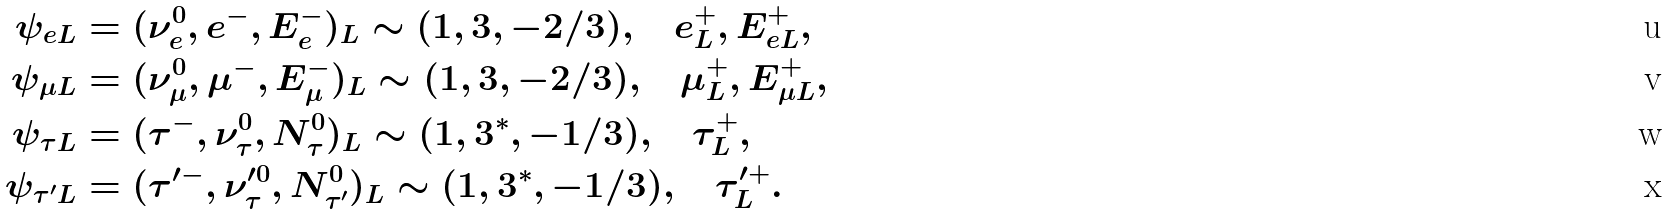<formula> <loc_0><loc_0><loc_500><loc_500>\psi _ { e L } & = ( \nu _ { e } ^ { 0 } , e ^ { - } , E ^ { - } _ { e } ) _ { L } \sim ( 1 , 3 , - 2 / 3 ) , \quad e ^ { + } _ { L } , E _ { e L } ^ { + } , \\ \psi _ { \mu L } & = ( \nu _ { \mu } ^ { 0 } , \mu ^ { - } , E ^ { - } _ { \mu } ) _ { L } \sim ( 1 , 3 , - 2 / 3 ) , \quad \mu ^ { + } _ { L } , E _ { \mu L } ^ { + } , \\ \psi _ { \tau L } & = ( \tau ^ { - } , \nu _ { \tau } ^ { 0 } , N ^ { 0 } _ { \tau } ) _ { L } \sim ( 1 , 3 ^ { * } , - 1 / 3 ) , \quad \tau ^ { + } _ { L } , \\ \psi _ { \tau ^ { \prime } L } & = ( \tau ^ { \prime - } , \nu _ { \tau } ^ { \prime 0 } , N ^ { 0 } _ { \tau ^ { \prime } } ) _ { L } \sim ( 1 , 3 ^ { * } , - 1 / 3 ) , \quad \tau ^ { \prime + } _ { L } .</formula> 